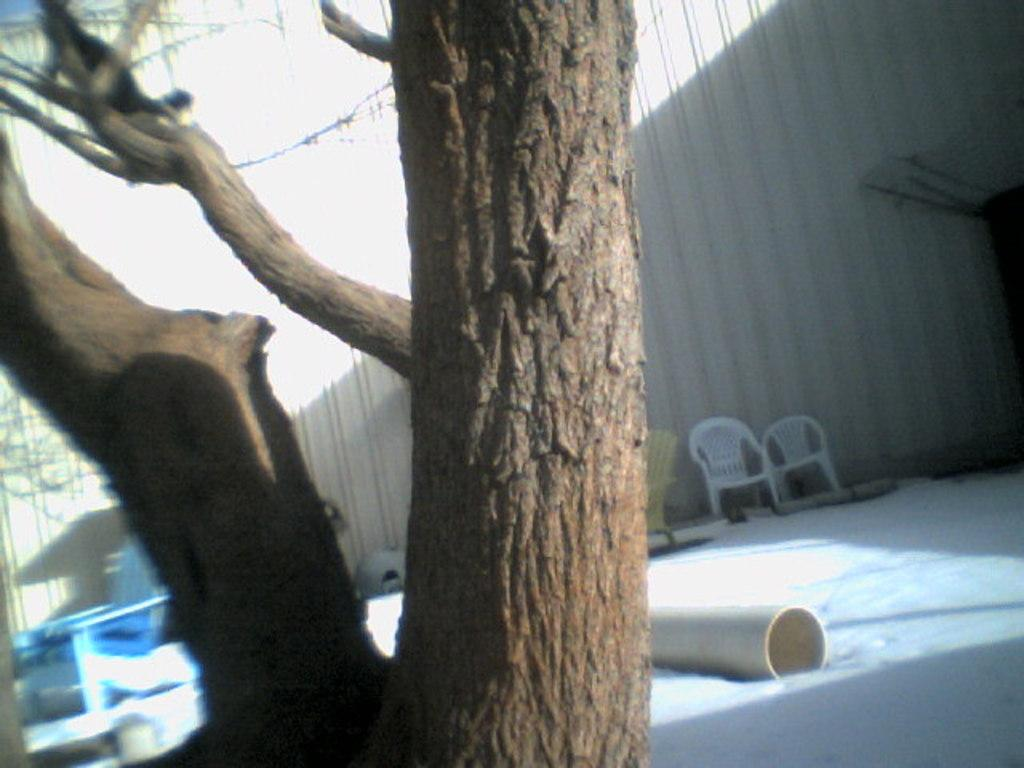What type of plant can be seen in the image? There is a tree in the image. What type of seating is available in the image? There is a bench and chairs in the image. What can be seen in the background of the image? There is a wall in the background of the image. What type of toy is being used in the battle depicted in the image? There is no battle or toy present in the image; it features a tree, bench, chairs, and a wall. 